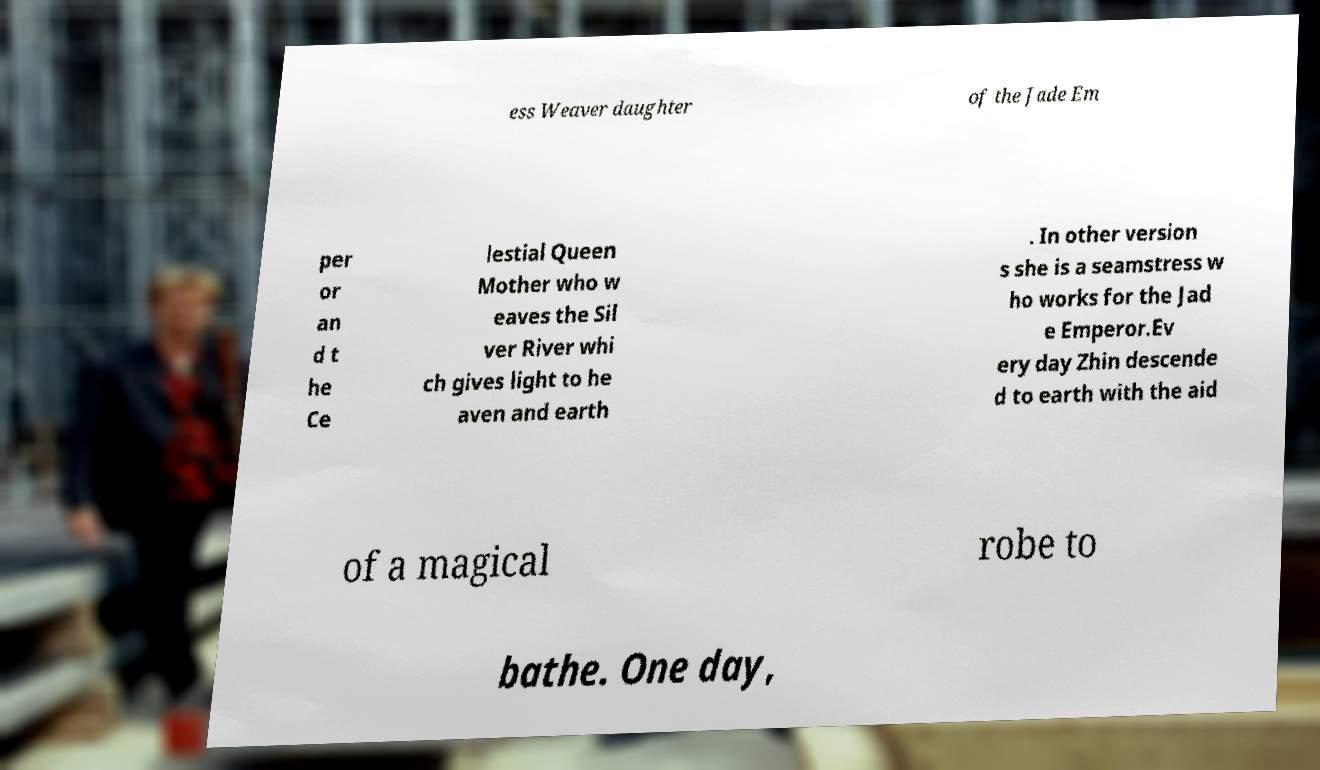What messages or text are displayed in this image? I need them in a readable, typed format. ess Weaver daughter of the Jade Em per or an d t he Ce lestial Queen Mother who w eaves the Sil ver River whi ch gives light to he aven and earth . In other version s she is a seamstress w ho works for the Jad e Emperor.Ev ery day Zhin descende d to earth with the aid of a magical robe to bathe. One day, 